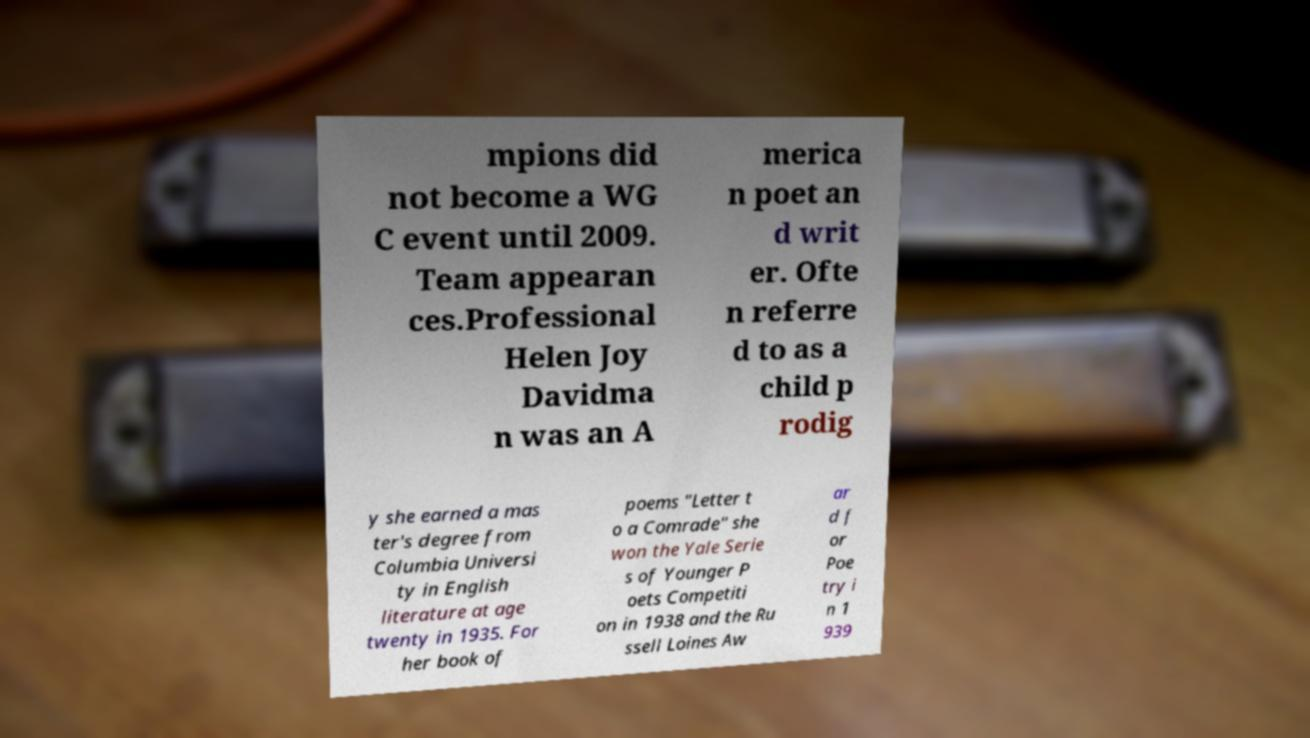Can you accurately transcribe the text from the provided image for me? mpions did not become a WG C event until 2009. Team appearan ces.Professional Helen Joy Davidma n was an A merica n poet an d writ er. Ofte n referre d to as a child p rodig y she earned a mas ter's degree from Columbia Universi ty in English literature at age twenty in 1935. For her book of poems "Letter t o a Comrade" she won the Yale Serie s of Younger P oets Competiti on in 1938 and the Ru ssell Loines Aw ar d f or Poe try i n 1 939 